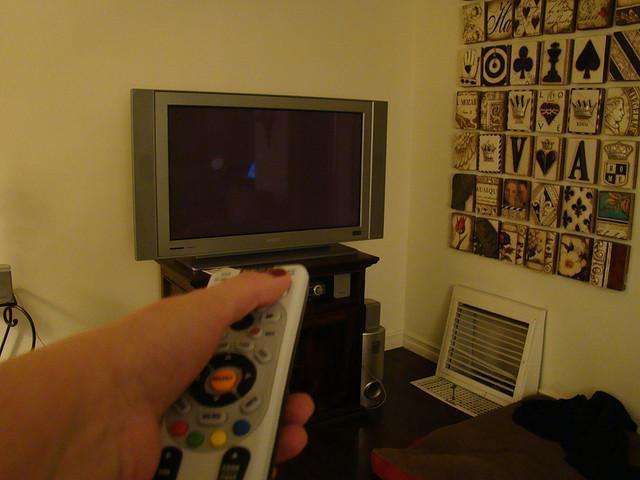Evaluate: Does the caption "The tv is behind the person." match the image?
Answer yes or no. No. 